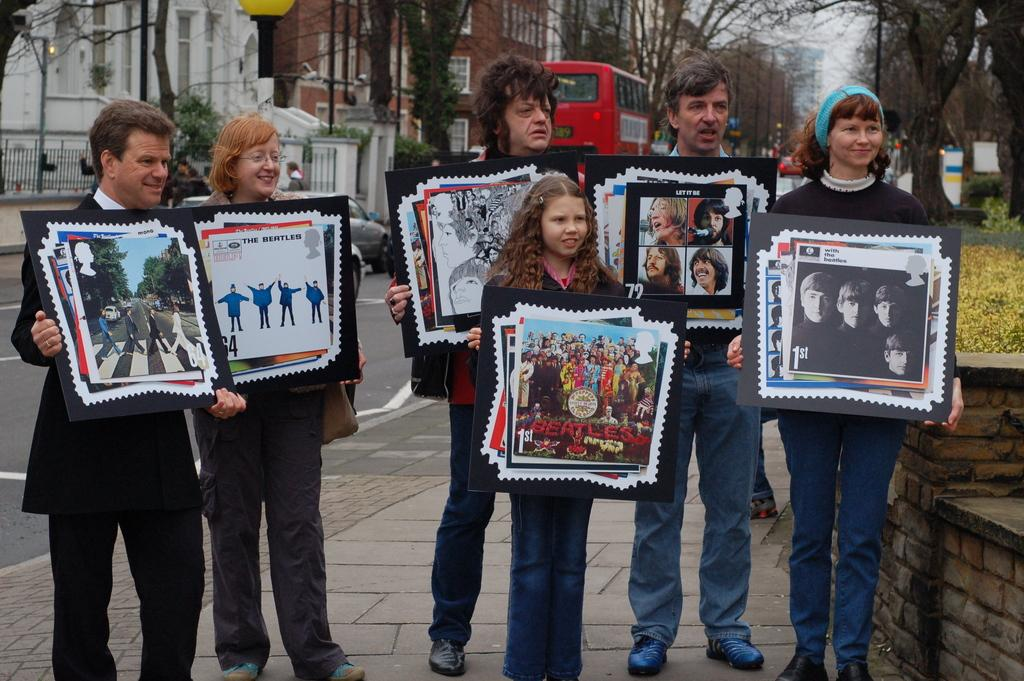Who or what can be seen in the image? There are people in the image. Where are the people located? The people are standing on a footpath. What are the people holding in their hands? The people are holding posters in their hands. How many porters are visible in the image? There are no porters present in the image; it features people holding posters on a footpath. Are the people in the image related as brothers? There is no information provided about the relationship between the people in the image, so it cannot be determined if they are brothers. 